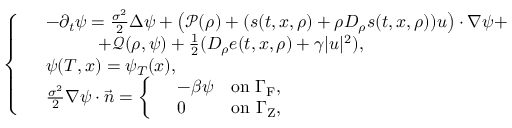<formula> <loc_0><loc_0><loc_500><loc_500>\left \{ \begin{array} { r l } & { - \partial _ { t } \psi = \frac { \sigma ^ { 2 } } { 2 } \Delta \psi + \left ( \mathcal { P } ( \rho ) + ( s ( t , x , \rho ) + \rho D _ { \rho } s ( t , x , \rho ) ) u \right ) \cdot \nabla \psi + } \\ & { \quad + \mathcal { Q } ( \rho , \psi ) + \frac { 1 } { 2 } ( D _ { \rho } e ( t , x , \rho ) + \gamma | u | ^ { 2 } ) , } \\ & { \psi ( T , x ) = \psi _ { T } ( x ) , } \\ & { \frac { \sigma ^ { 2 } } { 2 } \nabla \psi \cdot \vec { n } = \left \{ \begin{array} { r l r } & { - \beta \psi } & { o n \Gamma _ { F } , } \\ & { 0 } & { o n \Gamma _ { Z } , } \end{array} } \end{array}</formula> 